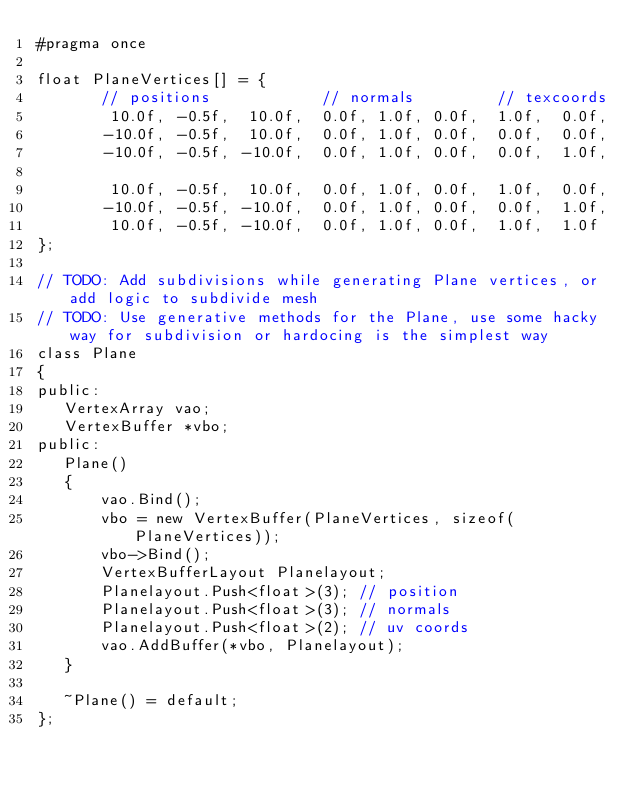<code> <loc_0><loc_0><loc_500><loc_500><_C_>#pragma once

float PlaneVertices[] = {
       // positions            // normals         // texcoords
        10.0f, -0.5f,  10.0f,  0.0f, 1.0f, 0.0f,  1.0f,  0.0f,
       -10.0f, -0.5f,  10.0f,  0.0f, 1.0f, 0.0f,  0.0f,  0.0f,
       -10.0f, -0.5f, -10.0f,  0.0f, 1.0f, 0.0f,  0.0f,  1.0f,

        10.0f, -0.5f,  10.0f,  0.0f, 1.0f, 0.0f,  1.0f,  0.0f,
       -10.0f, -0.5f, -10.0f,  0.0f, 1.0f, 0.0f,  0.0f,  1.0f,
        10.0f, -0.5f, -10.0f,  0.0f, 1.0f, 0.0f,  1.0f,  1.0f
};

// TODO: Add subdivisions while generating Plane vertices, or add logic to subdivide mesh
// TODO: Use generative methods for the Plane, use some hacky way for subdivision or hardocing is the simplest way
class Plane
{
public:
   VertexArray vao;
   VertexBuffer *vbo;
public:
   Plane()
   {
       vao.Bind();
       vbo = new VertexBuffer(PlaneVertices, sizeof(PlaneVertices));
       vbo->Bind();
       VertexBufferLayout Planelayout;
       Planelayout.Push<float>(3); // position
       Planelayout.Push<float>(3); // normals
       Planelayout.Push<float>(2); // uv coords
       vao.AddBuffer(*vbo, Planelayout);
   }

   ~Plane() = default;
};
</code> 